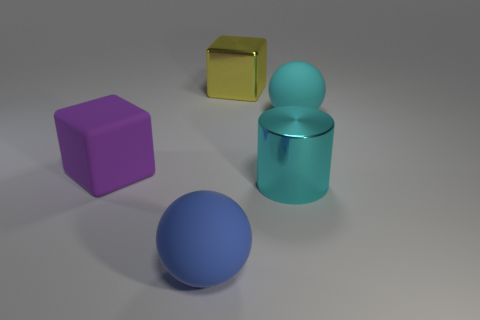What is the color of the big metallic thing on the right side of the shiny thing on the left side of the metal object on the right side of the yellow metal object?
Provide a short and direct response. Cyan. Are there any other things that have the same material as the big purple object?
Provide a succinct answer. Yes. Do the matte object on the left side of the large blue object and the big blue rubber thing have the same shape?
Ensure brevity in your answer.  No. What is the big purple block made of?
Give a very brief answer. Rubber. What shape is the metallic thing right of the block behind the large rubber object right of the yellow thing?
Offer a terse response. Cylinder. What number of other things are there of the same shape as the big cyan metal object?
Offer a very short reply. 0. There is a cylinder; is its color the same as the big rubber sphere behind the purple cube?
Provide a short and direct response. Yes. What number of yellow metallic blocks are there?
Provide a short and direct response. 1. What number of things are large yellow things or red matte cylinders?
Provide a succinct answer. 1. What is the size of the thing that is the same color as the large metallic cylinder?
Provide a succinct answer. Large. 